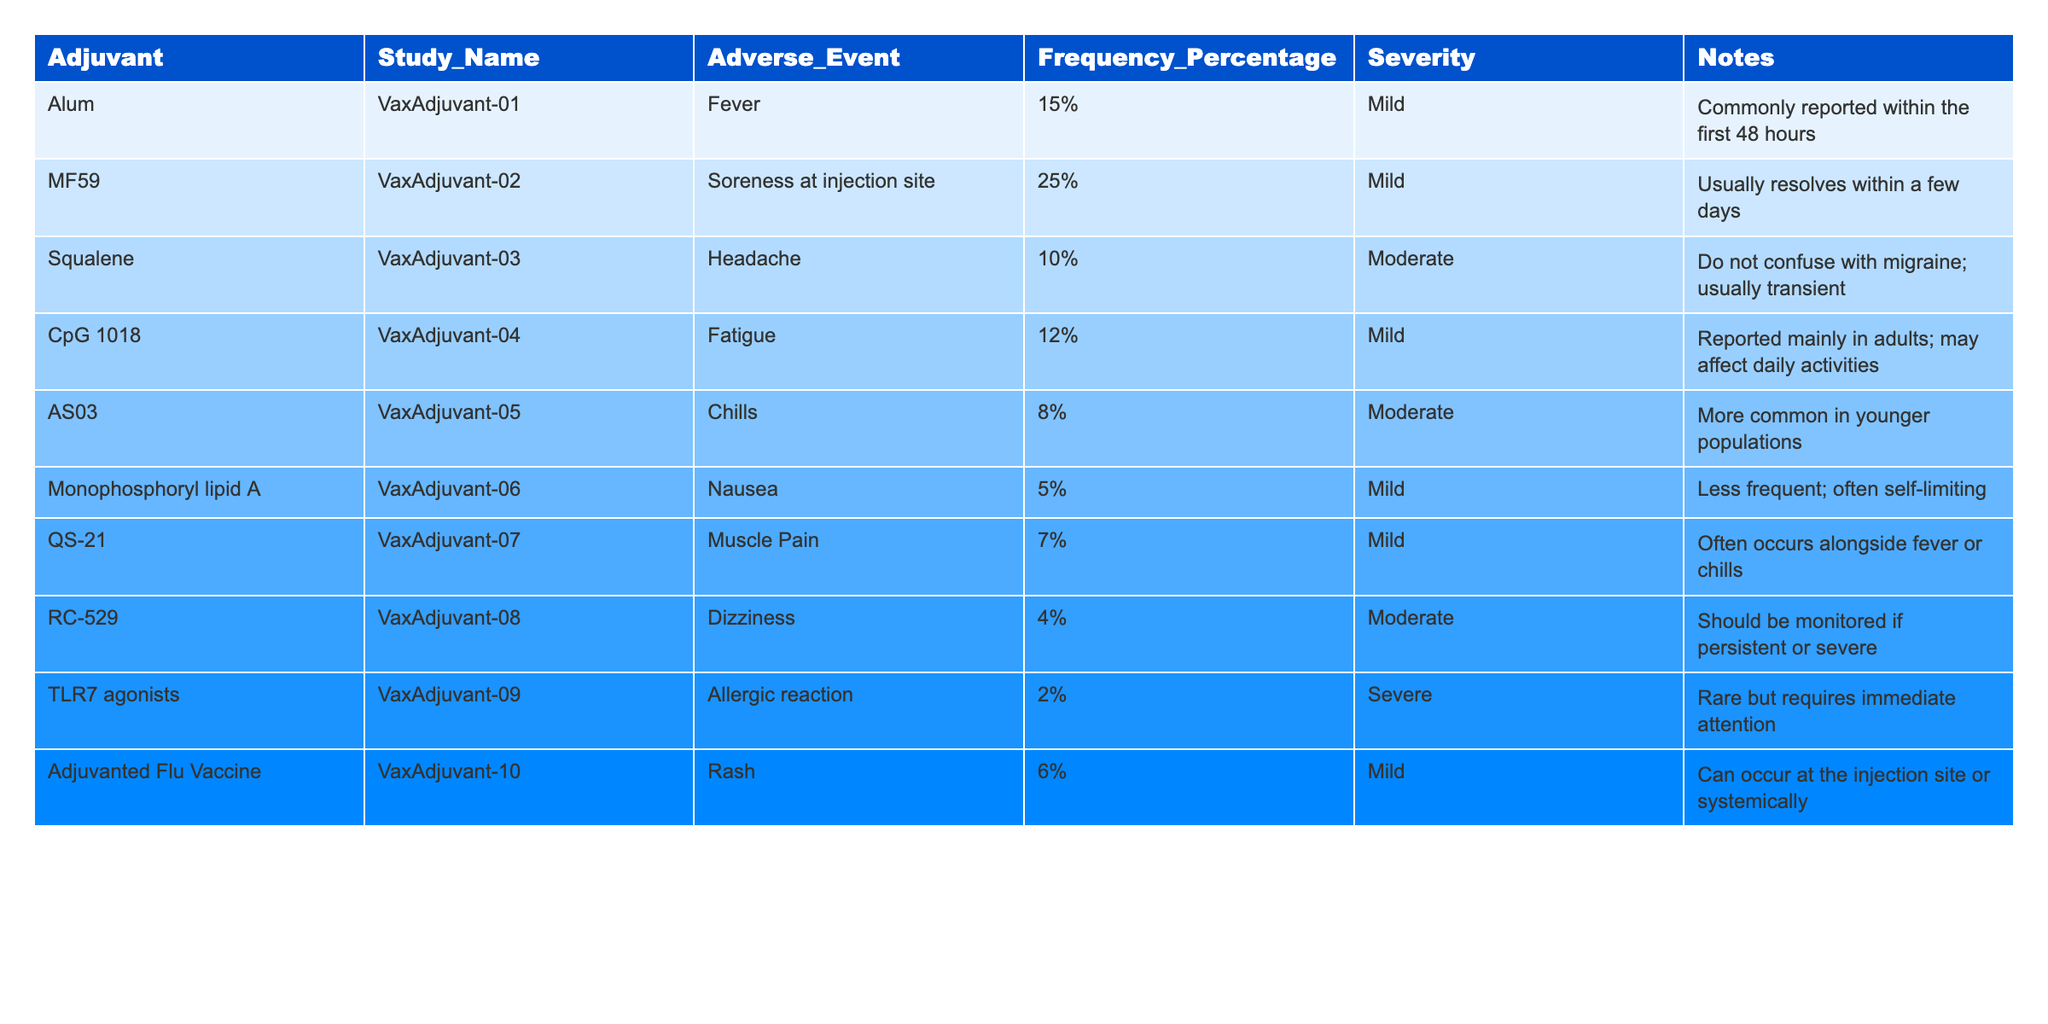What is the frequency percentage of soreness at the injection site for the MF59 adjuvant? In the table, under the 'MF59' row and 'Frequency_Percentage' column, the value listed is '25%'.
Answer: 25% Which adjuvant has the severest reported adverse event? The table indicates that the TLR7 agonists have an adverse event categorized as 'Severe', whereas others such as soreness and nausea are listed as 'Mild' or 'Moderate'.
Answer: TLR7 agonists What is the average frequency percentage of adverse events reported for all adjuvants? To find the average, we first sum the frequency percentages (15 + 25 + 10 + 12 + 8 + 5 + 7 + 4 + 2 + 6) = 94. There are 10 adjuvants, so we calculate 94/10 = 9.4%.
Answer: 9.4% How many adjuvants reported adverse events with a frequency percentage above 10%? By reviewing the table, the following adjuvants exceed 10%: MF59 (25%), Alum (15%), and CpG 1018 (12%). There are a total of 3.
Answer: 3 Is it true that all adverse events reported are mild or moderate? The table shows that there is one adverse event classified as 'Severe' (under TLR7 agonists), disproving the statement.
Answer: False What is the percentage difference in adverse event frequency between the highest and lowest reported values? The highest frequency is 25% (MF59) and the lowest is 2% (TLR7 agonists). The difference is calculated as 25 - 2 = 23%.
Answer: 23% Which adverse event was most commonly associated with the adjuvanted flu vaccine? The table shows that 'Rash' is listed under 'Adjuvanted Flu Vaccine', reported at a frequency of 6%.
Answer: Rash How many adverse events were reported with a frequency of less than 5%? The only event that falls into this category is 'Dizziness' at 4%, and 'Allergic reaction' at 2%, making the total of 2 events.
Answer: 2 Which adjuvant had the most common adverse event classified as 'Mild'? The adjuvant 'MF59' has the highest frequency percentage for a mild adverse event (25% for soreness at the injection site), which is the highest overall.
Answer: MF59 What notes are associated with the adverse event of nausea for Monophosphoryl lipid A? The table states, "Less frequent; often self-limiting" under the notes for nausea associated with Monophosphoryl lipid A.
Answer: Less frequent; often self-limiting 